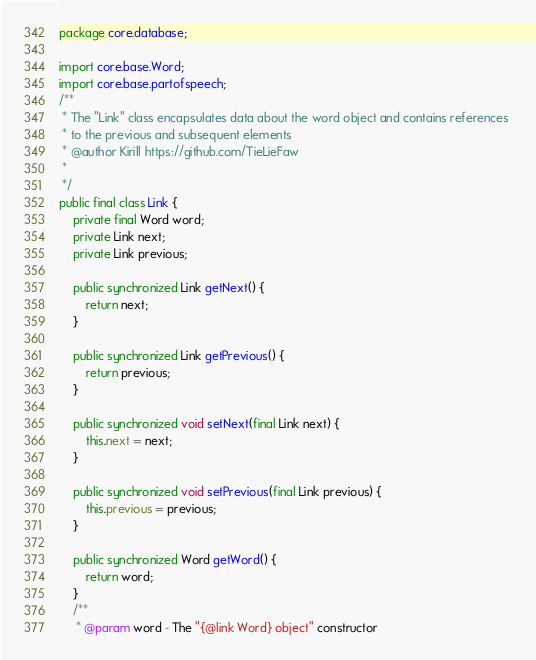Convert code to text. <code><loc_0><loc_0><loc_500><loc_500><_Java_>package core.database;

import core.base.Word;
import core.base.partofspeech;
/**
 * The "Link" class encapsulates data about the word object and contains references 
 * to the previous and subsequent elements
 * @author Kirill https://github.com/TieLieFaw
 *
 */
public final class Link {
	private final Word word;
	private Link next;
	private Link previous;
	
	public synchronized Link getNext() {
		return next;
	}
	
	public synchronized Link getPrevious() {
		return previous;
	}
	
	public synchronized void setNext(final Link next) {
		this.next = next;
	}
	
	public synchronized void setPrevious(final Link previous) {
		this.previous = previous;
	}
	
	public synchronized Word getWord() {
		return word;
	}
	/** 
	 * @param word - The "{@link Word} object" constructor</code> 